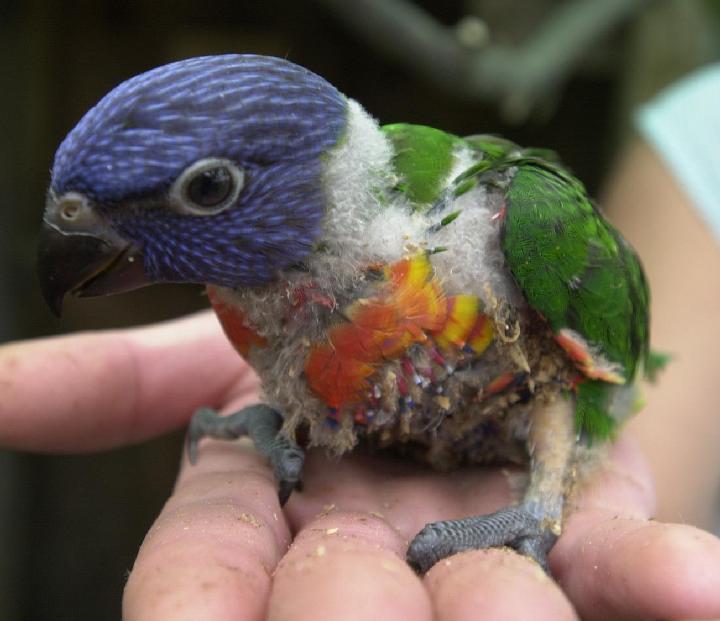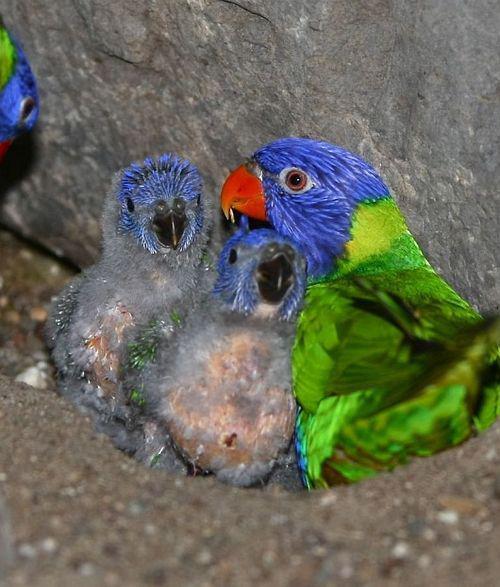The first image is the image on the left, the second image is the image on the right. Given the left and right images, does the statement "There are at most 4 birds pictured." hold true? Answer yes or no. Yes. 